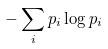Convert formula to latex. <formula><loc_0><loc_0><loc_500><loc_500>- \sum _ { i } p _ { i } \log p _ { i }</formula> 